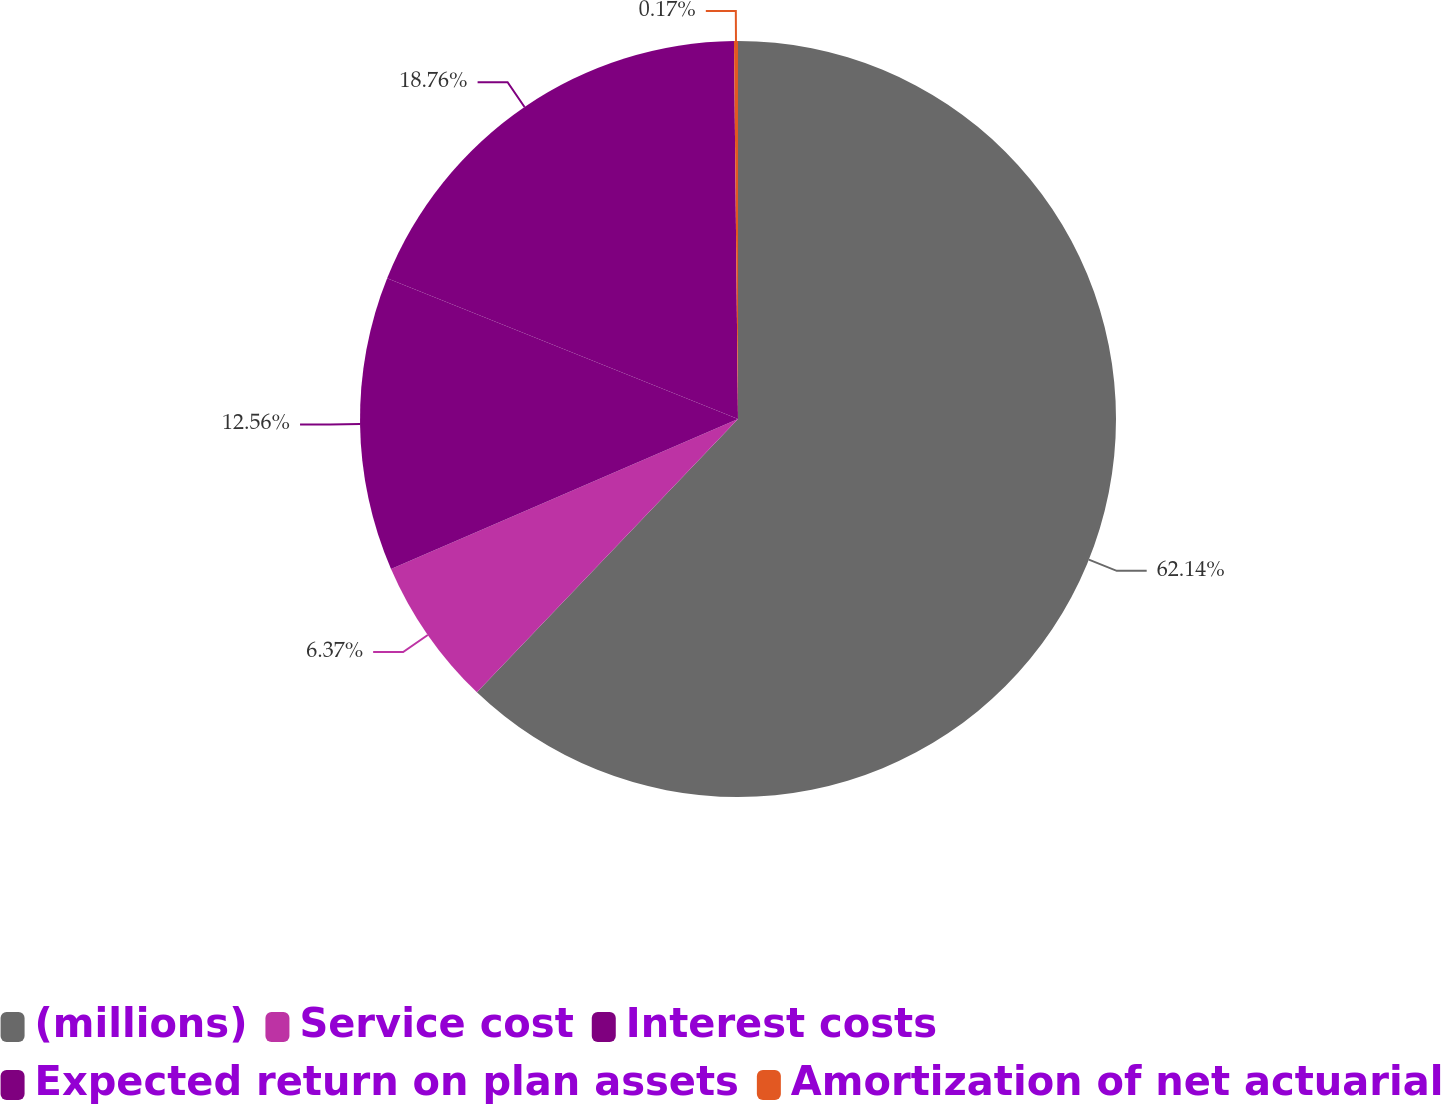Convert chart to OTSL. <chart><loc_0><loc_0><loc_500><loc_500><pie_chart><fcel>(millions)<fcel>Service cost<fcel>Interest costs<fcel>Expected return on plan assets<fcel>Amortization of net actuarial<nl><fcel>62.13%<fcel>6.37%<fcel>12.56%<fcel>18.76%<fcel>0.17%<nl></chart> 